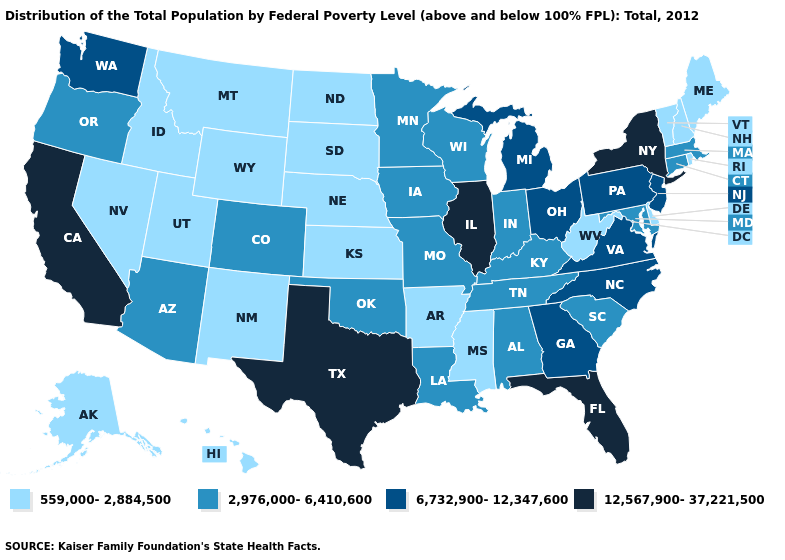Name the states that have a value in the range 6,732,900-12,347,600?
Concise answer only. Georgia, Michigan, New Jersey, North Carolina, Ohio, Pennsylvania, Virginia, Washington. Which states have the lowest value in the MidWest?
Keep it brief. Kansas, Nebraska, North Dakota, South Dakota. Which states have the highest value in the USA?
Concise answer only. California, Florida, Illinois, New York, Texas. What is the highest value in states that border Pennsylvania?
Give a very brief answer. 12,567,900-37,221,500. What is the value of Kansas?
Write a very short answer. 559,000-2,884,500. What is the value of Utah?
Be succinct. 559,000-2,884,500. What is the value of Montana?
Write a very short answer. 559,000-2,884,500. Name the states that have a value in the range 6,732,900-12,347,600?
Keep it brief. Georgia, Michigan, New Jersey, North Carolina, Ohio, Pennsylvania, Virginia, Washington. What is the value of Wisconsin?
Concise answer only. 2,976,000-6,410,600. Does Vermont have the highest value in the Northeast?
Keep it brief. No. What is the value of Kansas?
Keep it brief. 559,000-2,884,500. Name the states that have a value in the range 6,732,900-12,347,600?
Keep it brief. Georgia, Michigan, New Jersey, North Carolina, Ohio, Pennsylvania, Virginia, Washington. Which states hav the highest value in the Northeast?
Give a very brief answer. New York. What is the value of Iowa?
Write a very short answer. 2,976,000-6,410,600. 